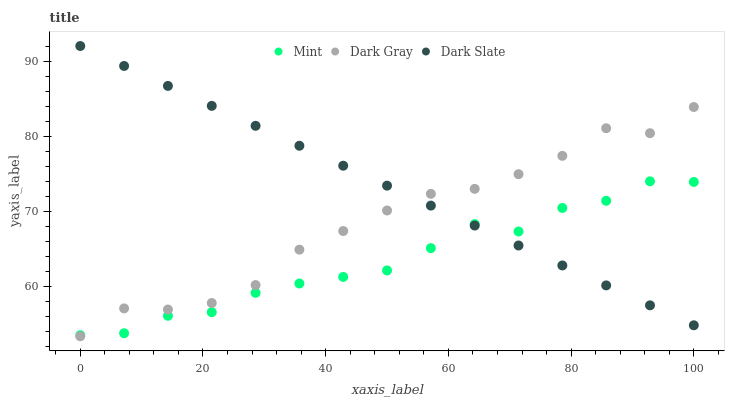Does Mint have the minimum area under the curve?
Answer yes or no. Yes. Does Dark Slate have the maximum area under the curve?
Answer yes or no. Yes. Does Dark Slate have the minimum area under the curve?
Answer yes or no. No. Does Mint have the maximum area under the curve?
Answer yes or no. No. Is Dark Slate the smoothest?
Answer yes or no. Yes. Is Mint the roughest?
Answer yes or no. Yes. Is Mint the smoothest?
Answer yes or no. No. Is Dark Slate the roughest?
Answer yes or no. No. Does Dark Gray have the lowest value?
Answer yes or no. Yes. Does Mint have the lowest value?
Answer yes or no. No. Does Dark Slate have the highest value?
Answer yes or no. Yes. Does Mint have the highest value?
Answer yes or no. No. Does Mint intersect Dark Gray?
Answer yes or no. Yes. Is Mint less than Dark Gray?
Answer yes or no. No. Is Mint greater than Dark Gray?
Answer yes or no. No. 